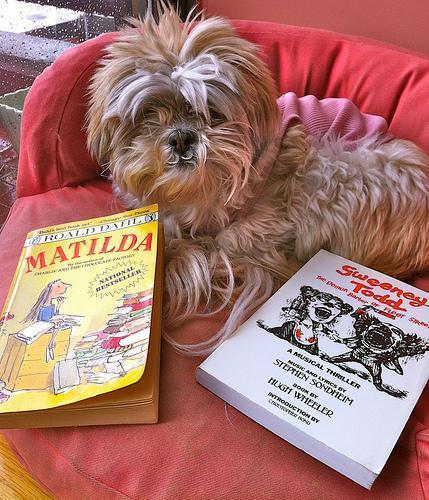How many books are in the picture?
Give a very brief answer. 2. 